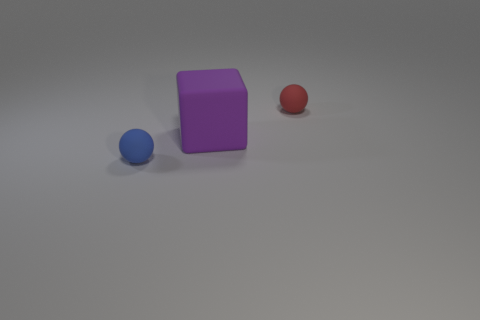What number of matte spheres are the same size as the blue matte thing?
Your answer should be compact. 1. Are there fewer red rubber things that are left of the small blue matte object than tiny blue objects?
Provide a short and direct response. Yes. What size is the ball that is on the left side of the tiny rubber object behind the small blue sphere?
Offer a very short reply. Small. How many things are either small red objects or tiny purple objects?
Offer a terse response. 1. Are there any rubber things of the same color as the big rubber block?
Your answer should be very brief. No. Are there fewer tiny brown cylinders than tiny spheres?
Your answer should be very brief. Yes. What number of things are either matte blocks or objects that are on the right side of the large purple object?
Offer a terse response. 2. Are there any other purple cubes made of the same material as the large purple block?
Offer a very short reply. No. What material is the ball that is the same size as the blue thing?
Make the answer very short. Rubber. What material is the sphere that is behind the sphere left of the red rubber ball made of?
Make the answer very short. Rubber. 